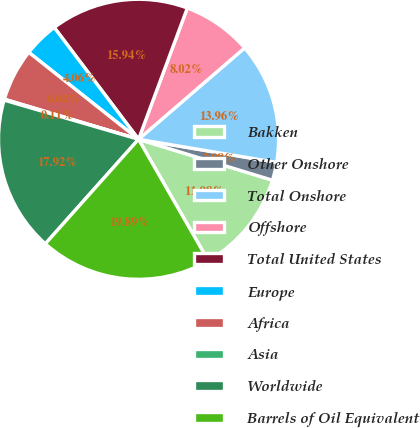Convert chart. <chart><loc_0><loc_0><loc_500><loc_500><pie_chart><fcel>Bakken<fcel>Other Onshore<fcel>Total Onshore<fcel>Offshore<fcel>Total United States<fcel>Europe<fcel>Africa<fcel>Asia<fcel>Worldwide<fcel>Barrels of Oil Equivalent<nl><fcel>11.98%<fcel>2.08%<fcel>13.96%<fcel>8.02%<fcel>15.94%<fcel>4.06%<fcel>6.04%<fcel>0.11%<fcel>17.92%<fcel>19.89%<nl></chart> 